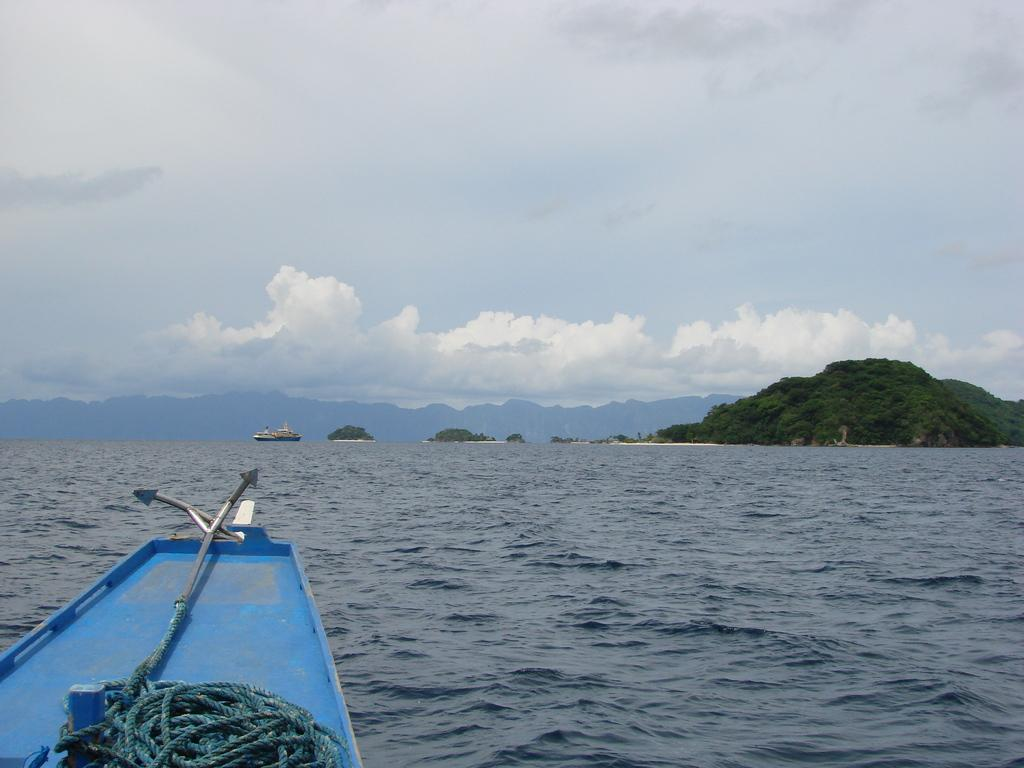What is the main subject of the image? There are boats on water in the image. What are the boats connected to or supported by? There are ropes visible in the image, which may be used to connect or support the boats. What type of natural environment is depicted in the image? There are trees and mountains in the image, indicating a natural environment. What is visible in the background of the image? The sky with clouds is visible in the background of the image. Can you tell me how many wings are visible on the boats in the image? There are no wings visible on the boats in the image; they are not aircraft. What type of conversation is happening between the trees in the image? There is no conversation happening between the trees in the image, as trees do not have the ability to talk. 